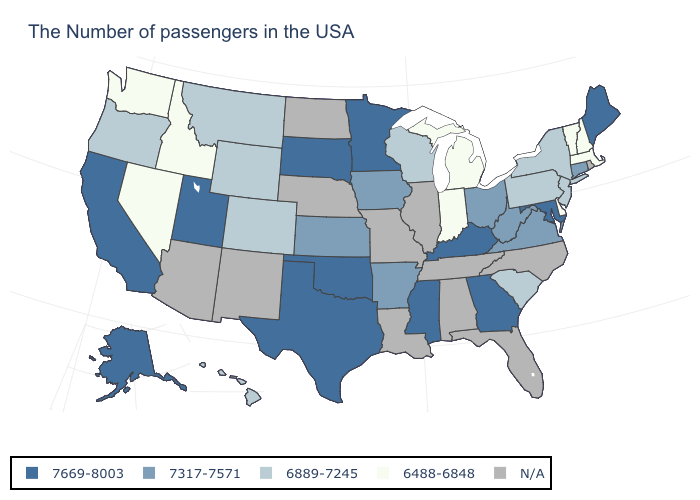Which states have the lowest value in the USA?
Concise answer only. Massachusetts, New Hampshire, Vermont, Delaware, Michigan, Indiana, Idaho, Nevada, Washington. What is the value of Rhode Island?
Short answer required. N/A. What is the lowest value in the USA?
Be succinct. 6488-6848. What is the lowest value in the USA?
Quick response, please. 6488-6848. Does the first symbol in the legend represent the smallest category?
Short answer required. No. Among the states that border Mississippi , which have the highest value?
Keep it brief. Arkansas. Among the states that border Wisconsin , which have the lowest value?
Give a very brief answer. Michigan. Does Michigan have the highest value in the USA?
Short answer required. No. What is the value of Missouri?
Answer briefly. N/A. Does the map have missing data?
Give a very brief answer. Yes. What is the value of Missouri?
Answer briefly. N/A. What is the value of California?
Quick response, please. 7669-8003. Does Delaware have the lowest value in the South?
Give a very brief answer. Yes. 